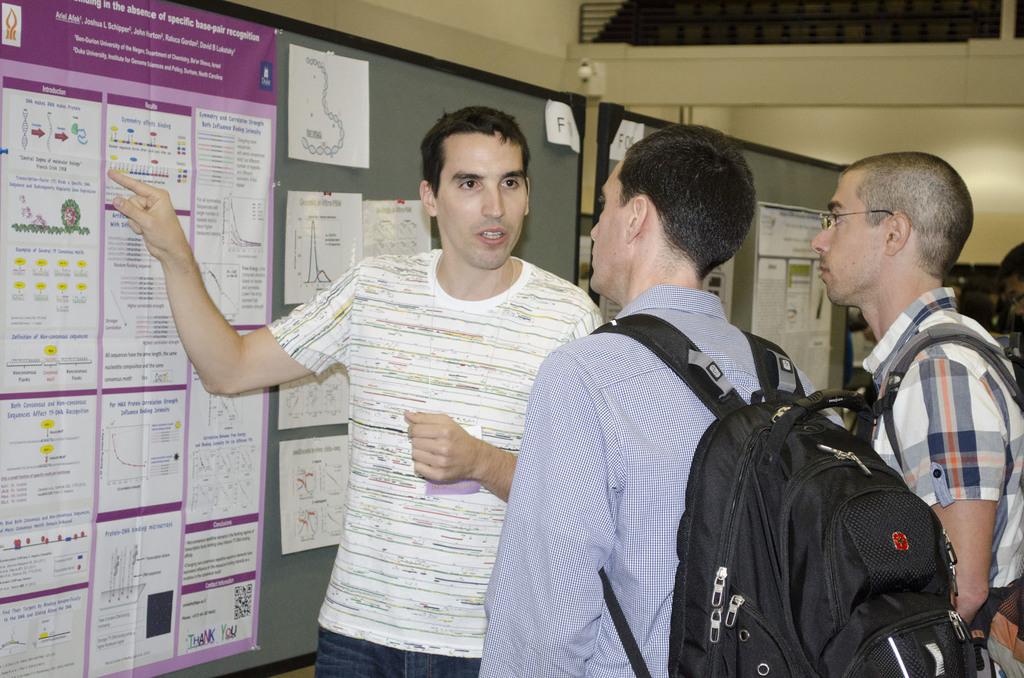Is there a paper with an f on one of those boards?
Provide a succinct answer. Yes. What is written on the bottom right of the sign?
Ensure brevity in your answer.  Thank you. 